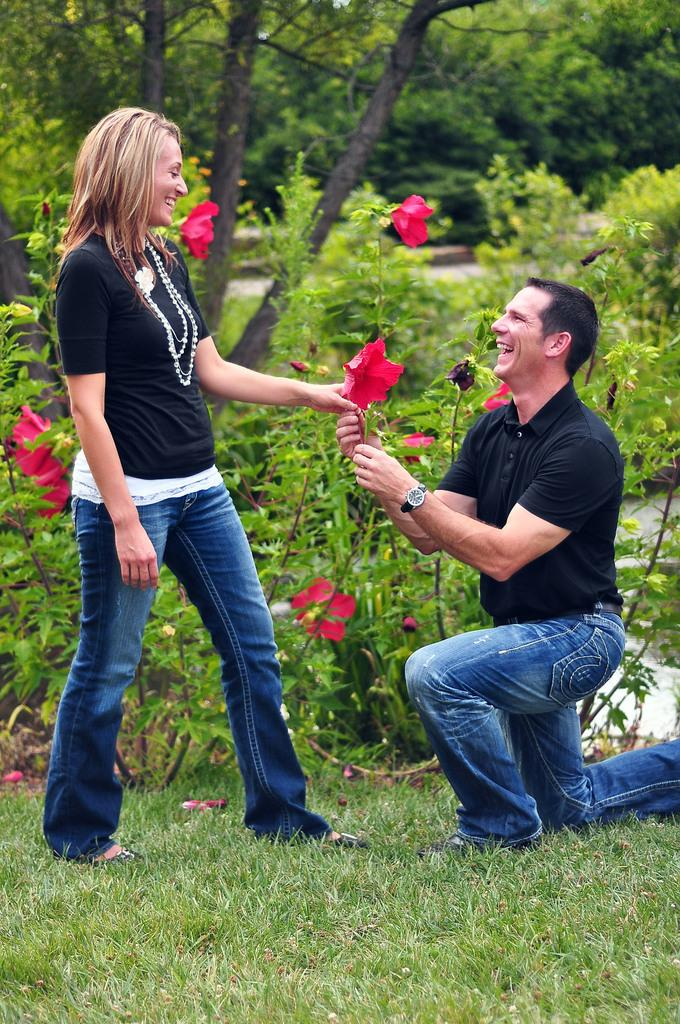What are the man and woman in the image wearing? The man and woman are both wearing a black shirt and blue jeans. What are the man and woman holding in the image? The man and woman are holding a red color flower. What is visible on the ground in the image? There is grass on the ground in the image. What can be seen in the background of the image? There are trees and plants in the background of the image. What type of ball is being used in the fight between the man and woman in the image? There is no fight or ball present in the image. What liquid is being poured on the plants in the background of the image? There is no liquid being poured on the plants in the image; the plants are simply visible in the background. 